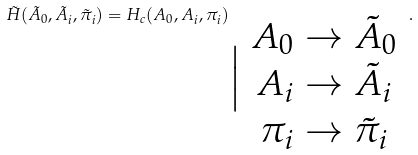<formula> <loc_0><loc_0><loc_500><loc_500>\tilde { H } ( \tilde { A } _ { 0 } , \tilde { A } _ { i } , \tilde { \pi } _ { i } ) = H _ { c } ( A _ { 0 } , A _ { i } , \pi _ { i } ) _ { \Big | \begin{array} { c } A _ { 0 } \rightarrow \tilde { A } _ { 0 } \\ A _ { i } \rightarrow \tilde { A } _ { i } \\ \pi _ { i } \rightarrow \tilde { \pi } _ { i } \end{array} } \, .</formula> 